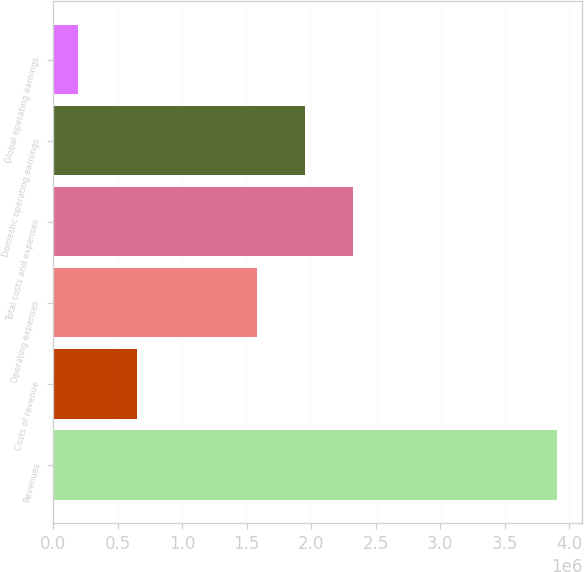Convert chart. <chart><loc_0><loc_0><loc_500><loc_500><bar_chart><fcel>Revenues<fcel>Costs of revenue<fcel>Operating expenses<fcel>Total costs and expenses<fcel>Domestic operating earnings<fcel>Global operating earnings<nl><fcel>3.90445e+06<fcel>651826<fcel>1.57759e+06<fcel>2.32072e+06<fcel>1.94916e+06<fcel>188811<nl></chart> 